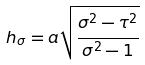Convert formula to latex. <formula><loc_0><loc_0><loc_500><loc_500>h _ { \sigma } = a \sqrt { \frac { \sigma ^ { 2 } - \tau ^ { 2 } } { \sigma ^ { 2 } - 1 } }</formula> 